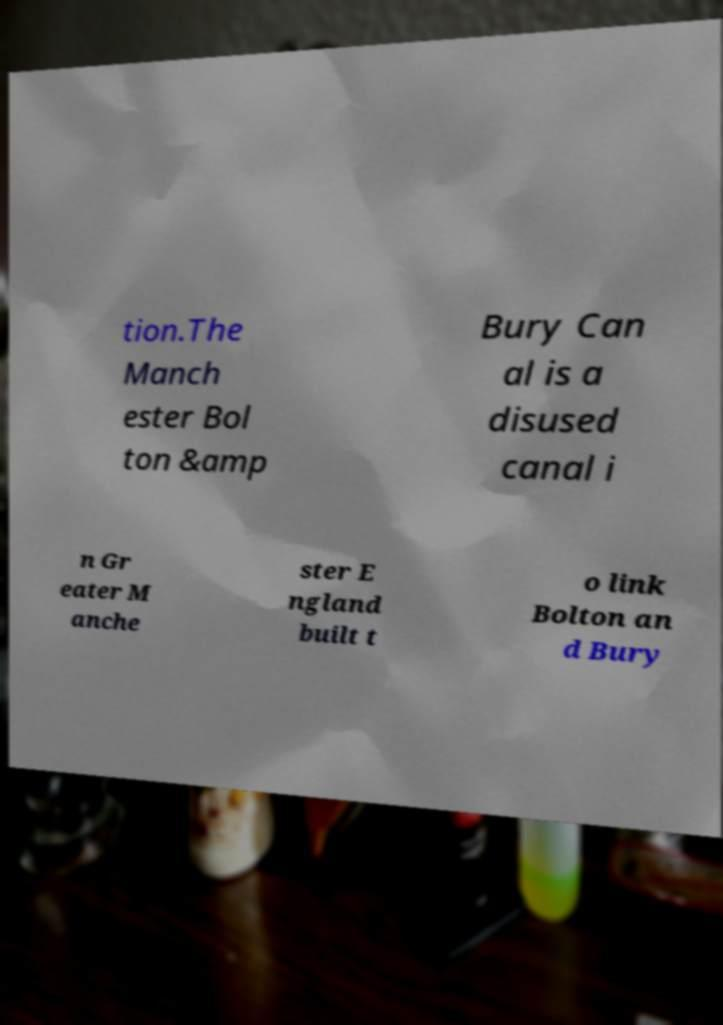What messages or text are displayed in this image? I need them in a readable, typed format. tion.The Manch ester Bol ton &amp Bury Can al is a disused canal i n Gr eater M anche ster E ngland built t o link Bolton an d Bury 